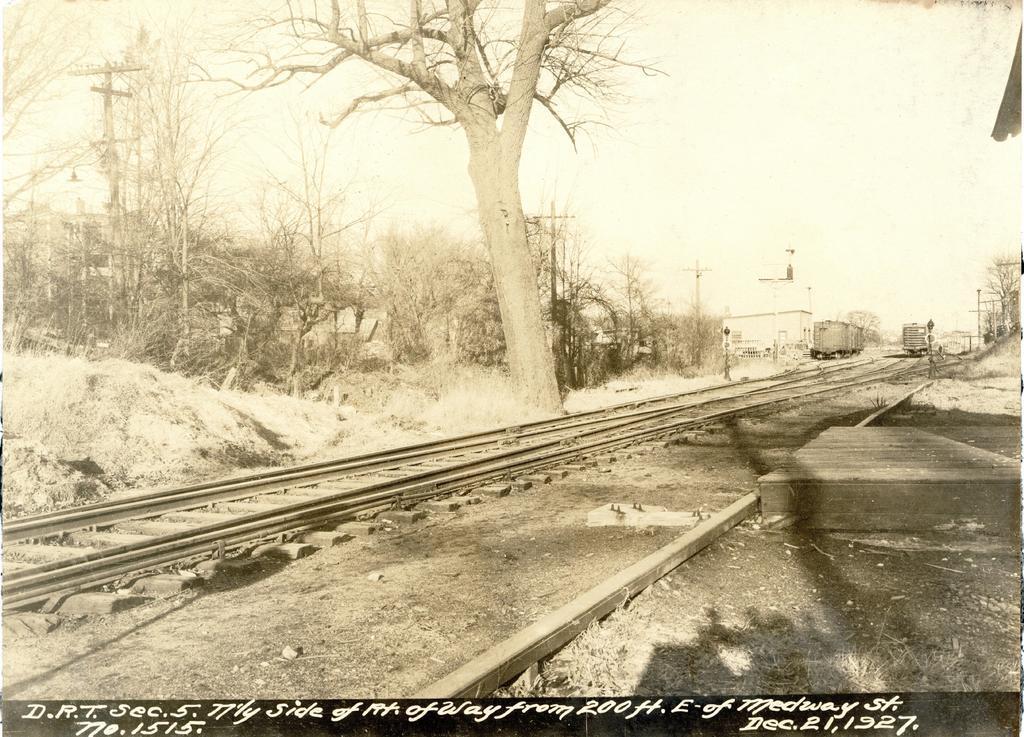Could you give a brief overview of what you see in this image? As we can see in the image there is a clear sky. On the ground there is a railway track on the other side of the track there is a engine standing and beside it there is a train on the track. Beside the goods train there is a building. There are lot of trees over here and here the tree is standing without leaves on it and on the bottom of the picture there is written which is in white colour. 